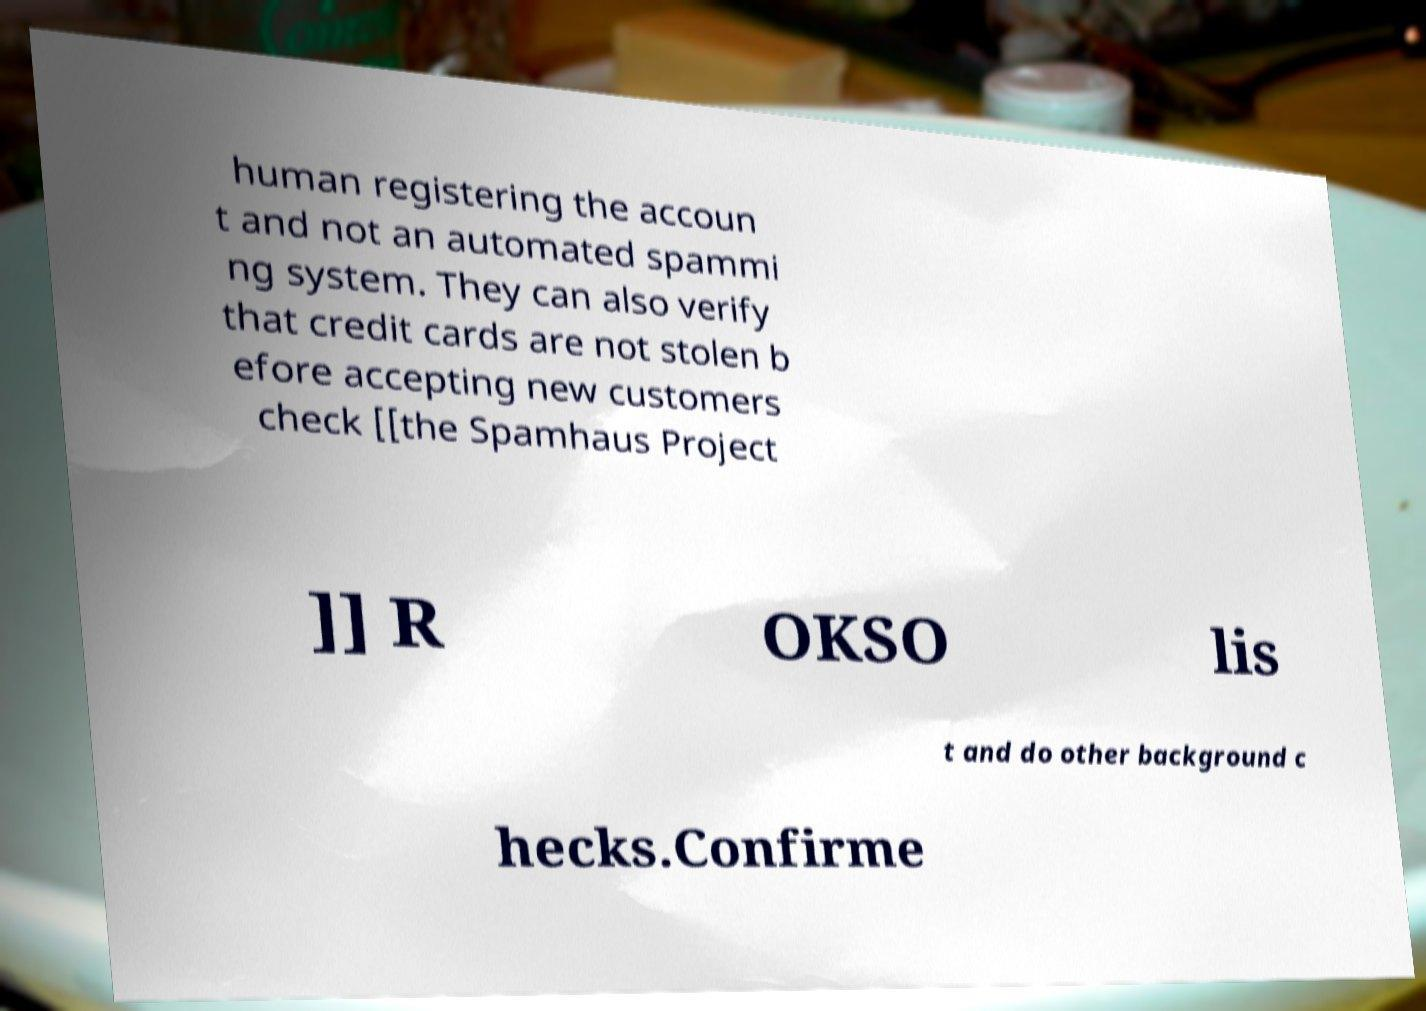For documentation purposes, I need the text within this image transcribed. Could you provide that? human registering the accoun t and not an automated spammi ng system. They can also verify that credit cards are not stolen b efore accepting new customers check [[the Spamhaus Project ]] R OKSO lis t and do other background c hecks.Confirme 